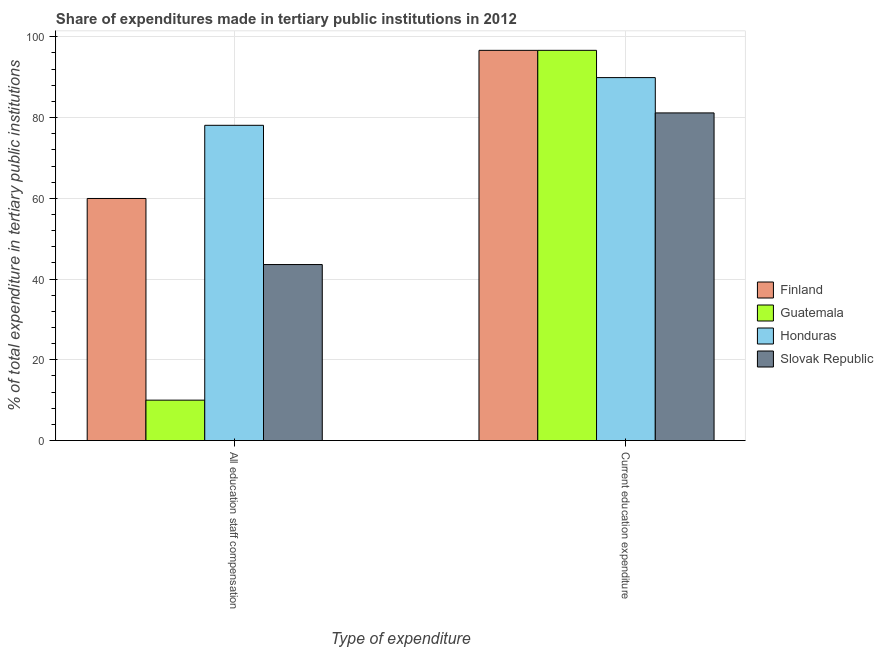How many groups of bars are there?
Your answer should be very brief. 2. Are the number of bars on each tick of the X-axis equal?
Give a very brief answer. Yes. How many bars are there on the 2nd tick from the left?
Give a very brief answer. 4. How many bars are there on the 1st tick from the right?
Your answer should be compact. 4. What is the label of the 1st group of bars from the left?
Ensure brevity in your answer.  All education staff compensation. What is the expenditure in education in Slovak Republic?
Ensure brevity in your answer.  81.16. Across all countries, what is the maximum expenditure in education?
Your answer should be compact. 96.66. Across all countries, what is the minimum expenditure in staff compensation?
Provide a short and direct response. 10.01. In which country was the expenditure in education maximum?
Your response must be concise. Guatemala. In which country was the expenditure in education minimum?
Your answer should be compact. Slovak Republic. What is the total expenditure in education in the graph?
Your answer should be compact. 364.38. What is the difference between the expenditure in education in Guatemala and that in Slovak Republic?
Provide a succinct answer. 15.5. What is the difference between the expenditure in education in Slovak Republic and the expenditure in staff compensation in Guatemala?
Ensure brevity in your answer.  71.15. What is the average expenditure in staff compensation per country?
Provide a succinct answer. 47.92. What is the difference between the expenditure in staff compensation and expenditure in education in Guatemala?
Offer a terse response. -86.65. In how many countries, is the expenditure in staff compensation greater than 56 %?
Your answer should be very brief. 2. What is the ratio of the expenditure in staff compensation in Finland to that in Slovak Republic?
Offer a very short reply. 1.38. In how many countries, is the expenditure in staff compensation greater than the average expenditure in staff compensation taken over all countries?
Make the answer very short. 2. What does the 1st bar from the left in Current education expenditure represents?
Give a very brief answer. Finland. What does the 1st bar from the right in All education staff compensation represents?
Provide a short and direct response. Slovak Republic. Are all the bars in the graph horizontal?
Keep it short and to the point. No. What is the difference between two consecutive major ticks on the Y-axis?
Offer a very short reply. 20. Are the values on the major ticks of Y-axis written in scientific E-notation?
Your answer should be compact. No. Where does the legend appear in the graph?
Offer a very short reply. Center right. How many legend labels are there?
Provide a short and direct response. 4. How are the legend labels stacked?
Give a very brief answer. Vertical. What is the title of the graph?
Offer a very short reply. Share of expenditures made in tertiary public institutions in 2012. Does "Upper middle income" appear as one of the legend labels in the graph?
Make the answer very short. No. What is the label or title of the X-axis?
Provide a short and direct response. Type of expenditure. What is the label or title of the Y-axis?
Make the answer very short. % of total expenditure in tertiary public institutions. What is the % of total expenditure in tertiary public institutions of Finland in All education staff compensation?
Provide a short and direct response. 59.96. What is the % of total expenditure in tertiary public institutions of Guatemala in All education staff compensation?
Your answer should be compact. 10.01. What is the % of total expenditure in tertiary public institutions of Honduras in All education staff compensation?
Make the answer very short. 78.09. What is the % of total expenditure in tertiary public institutions in Slovak Republic in All education staff compensation?
Give a very brief answer. 43.6. What is the % of total expenditure in tertiary public institutions of Finland in Current education expenditure?
Keep it short and to the point. 96.65. What is the % of total expenditure in tertiary public institutions in Guatemala in Current education expenditure?
Provide a succinct answer. 96.66. What is the % of total expenditure in tertiary public institutions in Honduras in Current education expenditure?
Ensure brevity in your answer.  89.9. What is the % of total expenditure in tertiary public institutions in Slovak Republic in Current education expenditure?
Ensure brevity in your answer.  81.16. Across all Type of expenditure, what is the maximum % of total expenditure in tertiary public institutions in Finland?
Make the answer very short. 96.65. Across all Type of expenditure, what is the maximum % of total expenditure in tertiary public institutions of Guatemala?
Your response must be concise. 96.66. Across all Type of expenditure, what is the maximum % of total expenditure in tertiary public institutions in Honduras?
Keep it short and to the point. 89.9. Across all Type of expenditure, what is the maximum % of total expenditure in tertiary public institutions of Slovak Republic?
Provide a short and direct response. 81.16. Across all Type of expenditure, what is the minimum % of total expenditure in tertiary public institutions of Finland?
Provide a succinct answer. 59.96. Across all Type of expenditure, what is the minimum % of total expenditure in tertiary public institutions of Guatemala?
Give a very brief answer. 10.01. Across all Type of expenditure, what is the minimum % of total expenditure in tertiary public institutions in Honduras?
Keep it short and to the point. 78.09. Across all Type of expenditure, what is the minimum % of total expenditure in tertiary public institutions in Slovak Republic?
Make the answer very short. 43.6. What is the total % of total expenditure in tertiary public institutions of Finland in the graph?
Make the answer very short. 156.62. What is the total % of total expenditure in tertiary public institutions in Guatemala in the graph?
Make the answer very short. 106.67. What is the total % of total expenditure in tertiary public institutions of Honduras in the graph?
Provide a short and direct response. 167.99. What is the total % of total expenditure in tertiary public institutions in Slovak Republic in the graph?
Your answer should be very brief. 124.76. What is the difference between the % of total expenditure in tertiary public institutions of Finland in All education staff compensation and that in Current education expenditure?
Your response must be concise. -36.69. What is the difference between the % of total expenditure in tertiary public institutions in Guatemala in All education staff compensation and that in Current education expenditure?
Your answer should be compact. -86.65. What is the difference between the % of total expenditure in tertiary public institutions in Honduras in All education staff compensation and that in Current education expenditure?
Make the answer very short. -11.81. What is the difference between the % of total expenditure in tertiary public institutions in Slovak Republic in All education staff compensation and that in Current education expenditure?
Your answer should be compact. -37.56. What is the difference between the % of total expenditure in tertiary public institutions of Finland in All education staff compensation and the % of total expenditure in tertiary public institutions of Guatemala in Current education expenditure?
Provide a short and direct response. -36.69. What is the difference between the % of total expenditure in tertiary public institutions in Finland in All education staff compensation and the % of total expenditure in tertiary public institutions in Honduras in Current education expenditure?
Offer a very short reply. -29.94. What is the difference between the % of total expenditure in tertiary public institutions in Finland in All education staff compensation and the % of total expenditure in tertiary public institutions in Slovak Republic in Current education expenditure?
Offer a very short reply. -21.19. What is the difference between the % of total expenditure in tertiary public institutions in Guatemala in All education staff compensation and the % of total expenditure in tertiary public institutions in Honduras in Current education expenditure?
Provide a short and direct response. -79.89. What is the difference between the % of total expenditure in tertiary public institutions in Guatemala in All education staff compensation and the % of total expenditure in tertiary public institutions in Slovak Republic in Current education expenditure?
Your response must be concise. -71.15. What is the difference between the % of total expenditure in tertiary public institutions of Honduras in All education staff compensation and the % of total expenditure in tertiary public institutions of Slovak Republic in Current education expenditure?
Your response must be concise. -3.07. What is the average % of total expenditure in tertiary public institutions in Finland per Type of expenditure?
Make the answer very short. 78.31. What is the average % of total expenditure in tertiary public institutions in Guatemala per Type of expenditure?
Ensure brevity in your answer.  53.34. What is the average % of total expenditure in tertiary public institutions of Honduras per Type of expenditure?
Make the answer very short. 84. What is the average % of total expenditure in tertiary public institutions of Slovak Republic per Type of expenditure?
Provide a succinct answer. 62.38. What is the difference between the % of total expenditure in tertiary public institutions in Finland and % of total expenditure in tertiary public institutions in Guatemala in All education staff compensation?
Provide a succinct answer. 49.95. What is the difference between the % of total expenditure in tertiary public institutions of Finland and % of total expenditure in tertiary public institutions of Honduras in All education staff compensation?
Your answer should be very brief. -18.13. What is the difference between the % of total expenditure in tertiary public institutions of Finland and % of total expenditure in tertiary public institutions of Slovak Republic in All education staff compensation?
Your answer should be very brief. 16.37. What is the difference between the % of total expenditure in tertiary public institutions in Guatemala and % of total expenditure in tertiary public institutions in Honduras in All education staff compensation?
Provide a succinct answer. -68.08. What is the difference between the % of total expenditure in tertiary public institutions of Guatemala and % of total expenditure in tertiary public institutions of Slovak Republic in All education staff compensation?
Offer a very short reply. -33.58. What is the difference between the % of total expenditure in tertiary public institutions in Honduras and % of total expenditure in tertiary public institutions in Slovak Republic in All education staff compensation?
Provide a succinct answer. 34.49. What is the difference between the % of total expenditure in tertiary public institutions in Finland and % of total expenditure in tertiary public institutions in Guatemala in Current education expenditure?
Give a very brief answer. -0. What is the difference between the % of total expenditure in tertiary public institutions in Finland and % of total expenditure in tertiary public institutions in Honduras in Current education expenditure?
Your answer should be very brief. 6.75. What is the difference between the % of total expenditure in tertiary public institutions of Finland and % of total expenditure in tertiary public institutions of Slovak Republic in Current education expenditure?
Provide a short and direct response. 15.5. What is the difference between the % of total expenditure in tertiary public institutions of Guatemala and % of total expenditure in tertiary public institutions of Honduras in Current education expenditure?
Offer a terse response. 6.75. What is the difference between the % of total expenditure in tertiary public institutions in Guatemala and % of total expenditure in tertiary public institutions in Slovak Republic in Current education expenditure?
Offer a very short reply. 15.5. What is the difference between the % of total expenditure in tertiary public institutions in Honduras and % of total expenditure in tertiary public institutions in Slovak Republic in Current education expenditure?
Make the answer very short. 8.75. What is the ratio of the % of total expenditure in tertiary public institutions in Finland in All education staff compensation to that in Current education expenditure?
Ensure brevity in your answer.  0.62. What is the ratio of the % of total expenditure in tertiary public institutions of Guatemala in All education staff compensation to that in Current education expenditure?
Make the answer very short. 0.1. What is the ratio of the % of total expenditure in tertiary public institutions of Honduras in All education staff compensation to that in Current education expenditure?
Make the answer very short. 0.87. What is the ratio of the % of total expenditure in tertiary public institutions of Slovak Republic in All education staff compensation to that in Current education expenditure?
Your answer should be compact. 0.54. What is the difference between the highest and the second highest % of total expenditure in tertiary public institutions in Finland?
Your answer should be compact. 36.69. What is the difference between the highest and the second highest % of total expenditure in tertiary public institutions of Guatemala?
Offer a terse response. 86.65. What is the difference between the highest and the second highest % of total expenditure in tertiary public institutions in Honduras?
Keep it short and to the point. 11.81. What is the difference between the highest and the second highest % of total expenditure in tertiary public institutions of Slovak Republic?
Offer a terse response. 37.56. What is the difference between the highest and the lowest % of total expenditure in tertiary public institutions in Finland?
Your response must be concise. 36.69. What is the difference between the highest and the lowest % of total expenditure in tertiary public institutions in Guatemala?
Your answer should be compact. 86.65. What is the difference between the highest and the lowest % of total expenditure in tertiary public institutions of Honduras?
Make the answer very short. 11.81. What is the difference between the highest and the lowest % of total expenditure in tertiary public institutions of Slovak Republic?
Give a very brief answer. 37.56. 